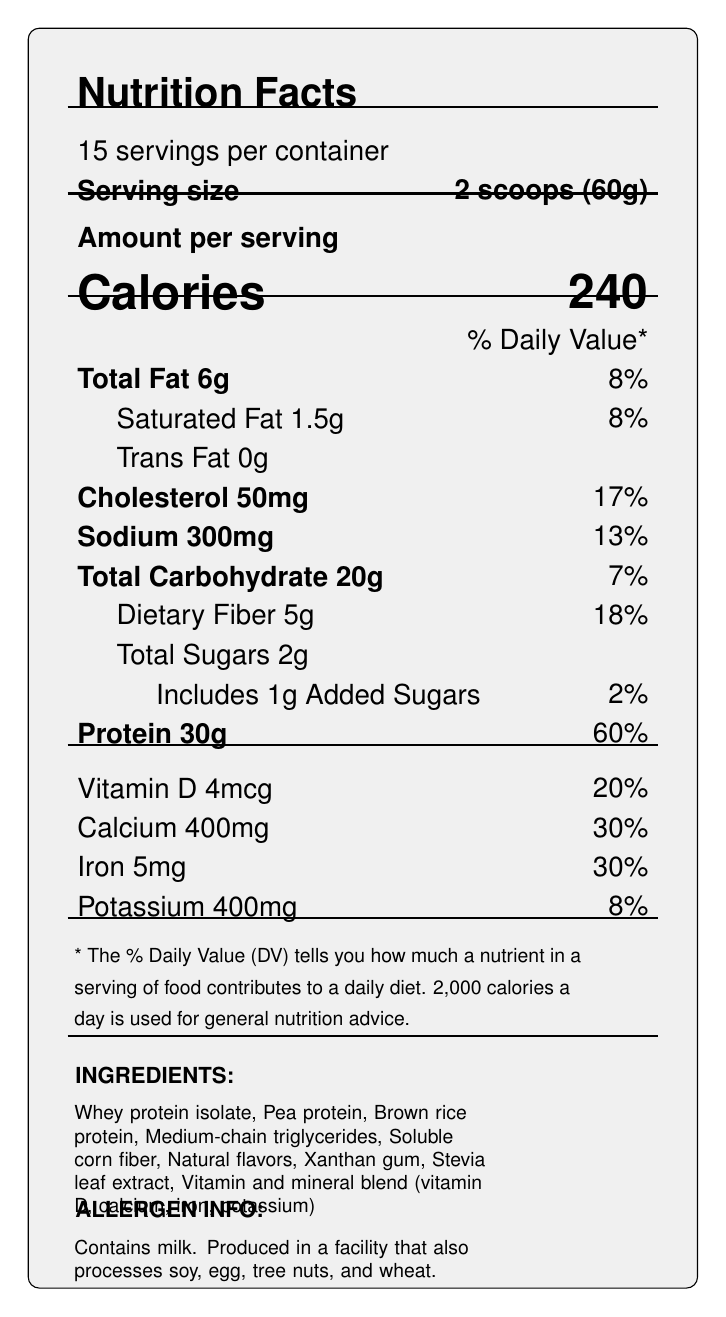what is the serving size of the TechFuel Pro Meal Replacement Shake? The serving size is clearly stated as "2 scoops (60g)" on the label.
Answer: 2 scoops (60g) how many servings are there per container? The label mentions "15 servings per container."
Answer: 15 servings what is the amount of protein per serving? Under the protein section, it states "Protein 30g."
Answer: 30g how much dietary fiber is in each serving? The dietary fiber content is stated as "Dietary Fiber 5g."
Answer: 5g what percentage of the daily value of calcium does one serving provide? The document mentions "Calcium 400mg" and its daily value contribution as "30%."
Answer: 30% which essential amino acid has the highest amount per serving? Leucine has the highest amount per serving, listed as "Leucine: 2.5g."
Answer: Leucine how many calories are there in one serving? The label lists the calorie content as "Calories 240."
Answer: 240 calories what ingredients are included in the TechFuel Pro Meal Replacement Shake? The ingredients section lists all these items.
Answer: Whey protein isolate, Pea protein, Brown rice protein, Medium-chain triglycerides, Soluble corn fiber, Natural flavors, Xanthan gum, Stevia leaf extract, Vitamin and mineral blend (vitamin D, calcium, iron, potassium) What is the main source of protein in this meal replacement shake? A. Whey Protein Isolate B. Pea Protein C. Soy Protein Among the ingredients, "Whey Protein Isolate" is listed first, usually indicating it is the main source.
Answer: A. Whey Protein Isolate How much added sugar is included per serving? A. 0g B. 1g C. 2g D. 5g The label specifies "Added Sugars 1g."
Answer: B. 1g Does the TechFuel Pro Meal Replacement Shake contain any artificial flavors? The ingredient list mentions "Natural flavors," not artificial ones.
Answer: No Is the product NSF Certified for Sport? The label mentions the certification as "NSF Certified for Sport."
Answer: Yes Summarize the main nutritional information and features of the TechFuel Pro Meal Replacement Shake. This summary covers the core aspects such as caloric content, macronutrients, vitamins and minerals, ingredient list, certifications, and allergen information provided on the label.
Answer: The TechFuel Pro Meal Replacement Shake provides 240 calories per serving, with 30g of protein, 20g of carbohydrates, and 6g of fat. It contains essential vitamins and minerals, including 30% of the daily value for calcium and iron. The shake also offers a detailed breakdown of essential amino acids. It contains natural flavors, stevia leaf extract and is NSF Certified for Sport. It contains milk and may be processed in facilities with other allergens. What is the proportion of calories coming from protein in this shake? The label provides the amount of protein but does not specify the calorie count per gram for protein to calculate the proportion.
Answer: Not enough information 